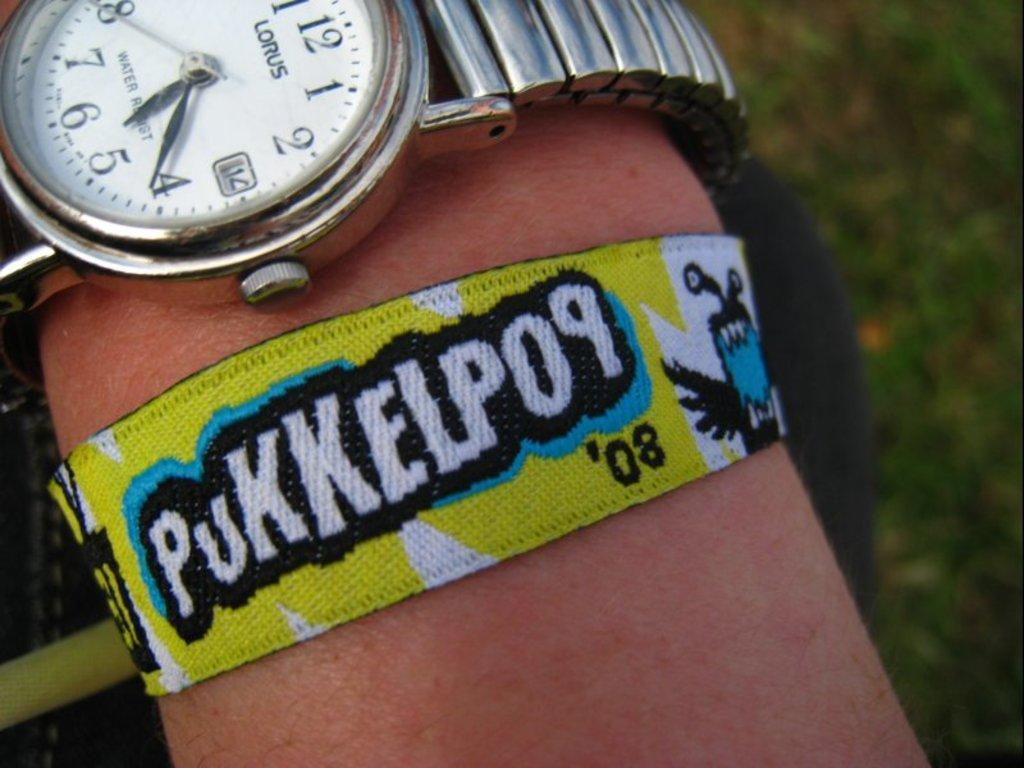<image>
Share a concise interpretation of the image provided. A cose up of a persons wrist which has a Lorus watch around it and a Pukkelpop '08 entrance band 